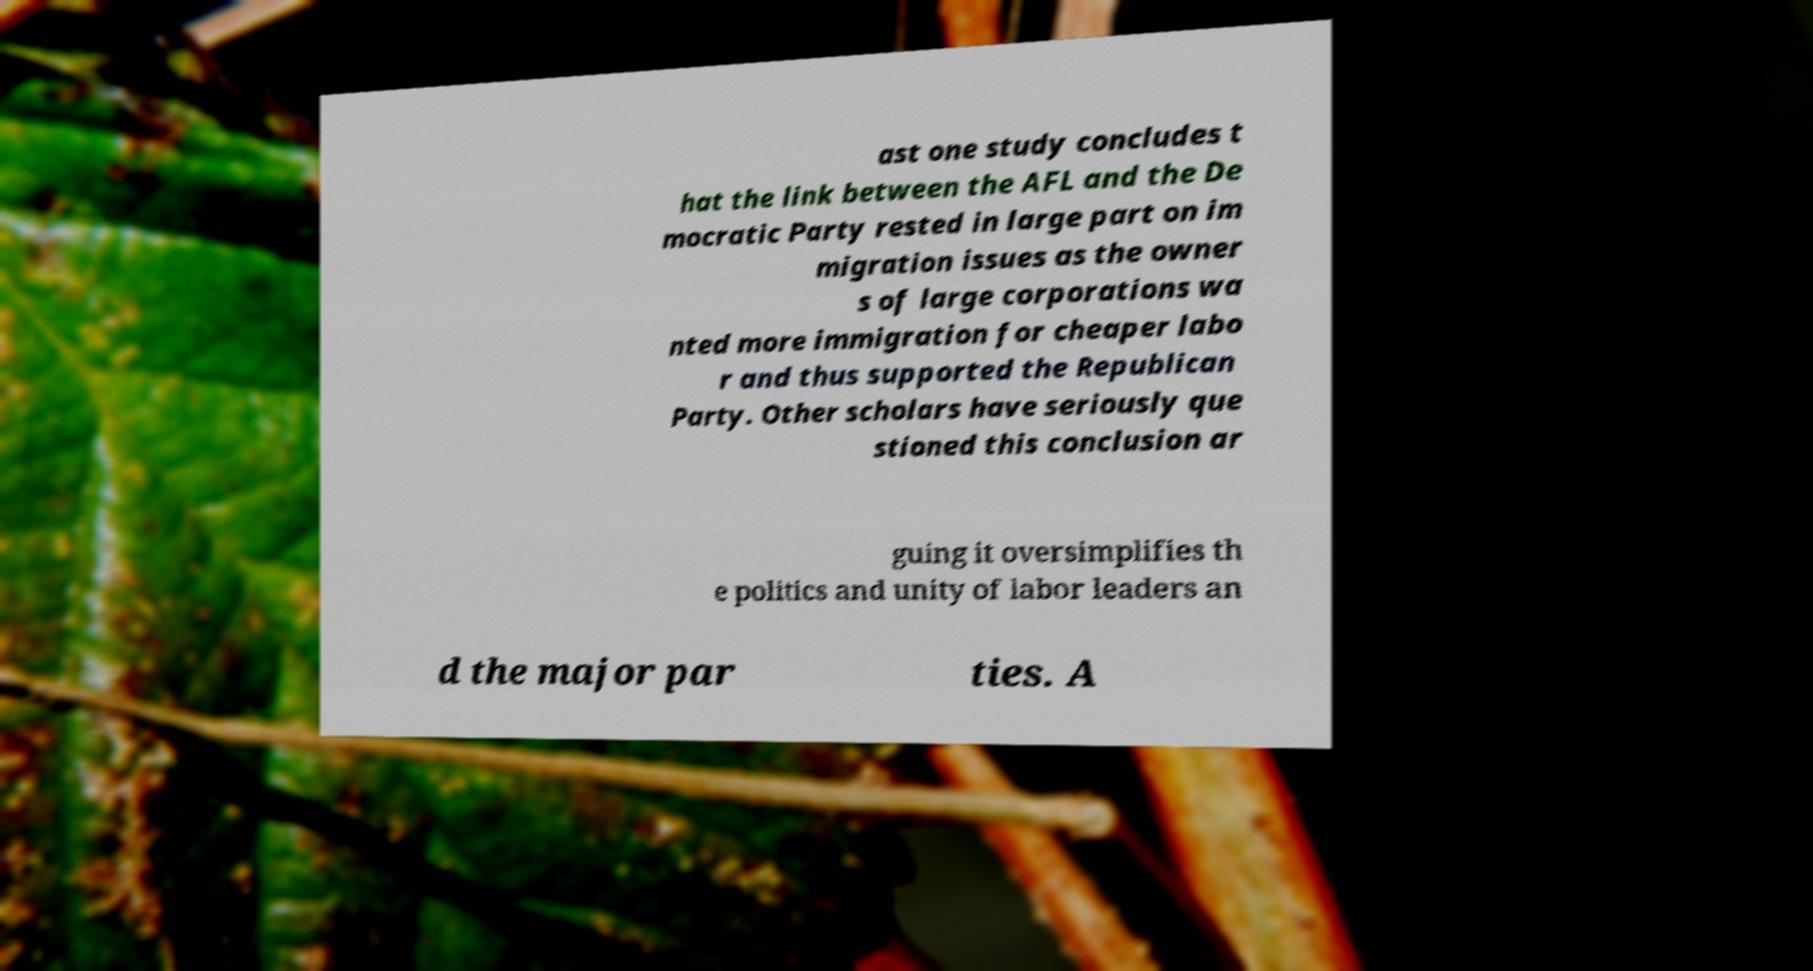For documentation purposes, I need the text within this image transcribed. Could you provide that? ast one study concludes t hat the link between the AFL and the De mocratic Party rested in large part on im migration issues as the owner s of large corporations wa nted more immigration for cheaper labo r and thus supported the Republican Party. Other scholars have seriously que stioned this conclusion ar guing it oversimplifies th e politics and unity of labor leaders an d the major par ties. A 